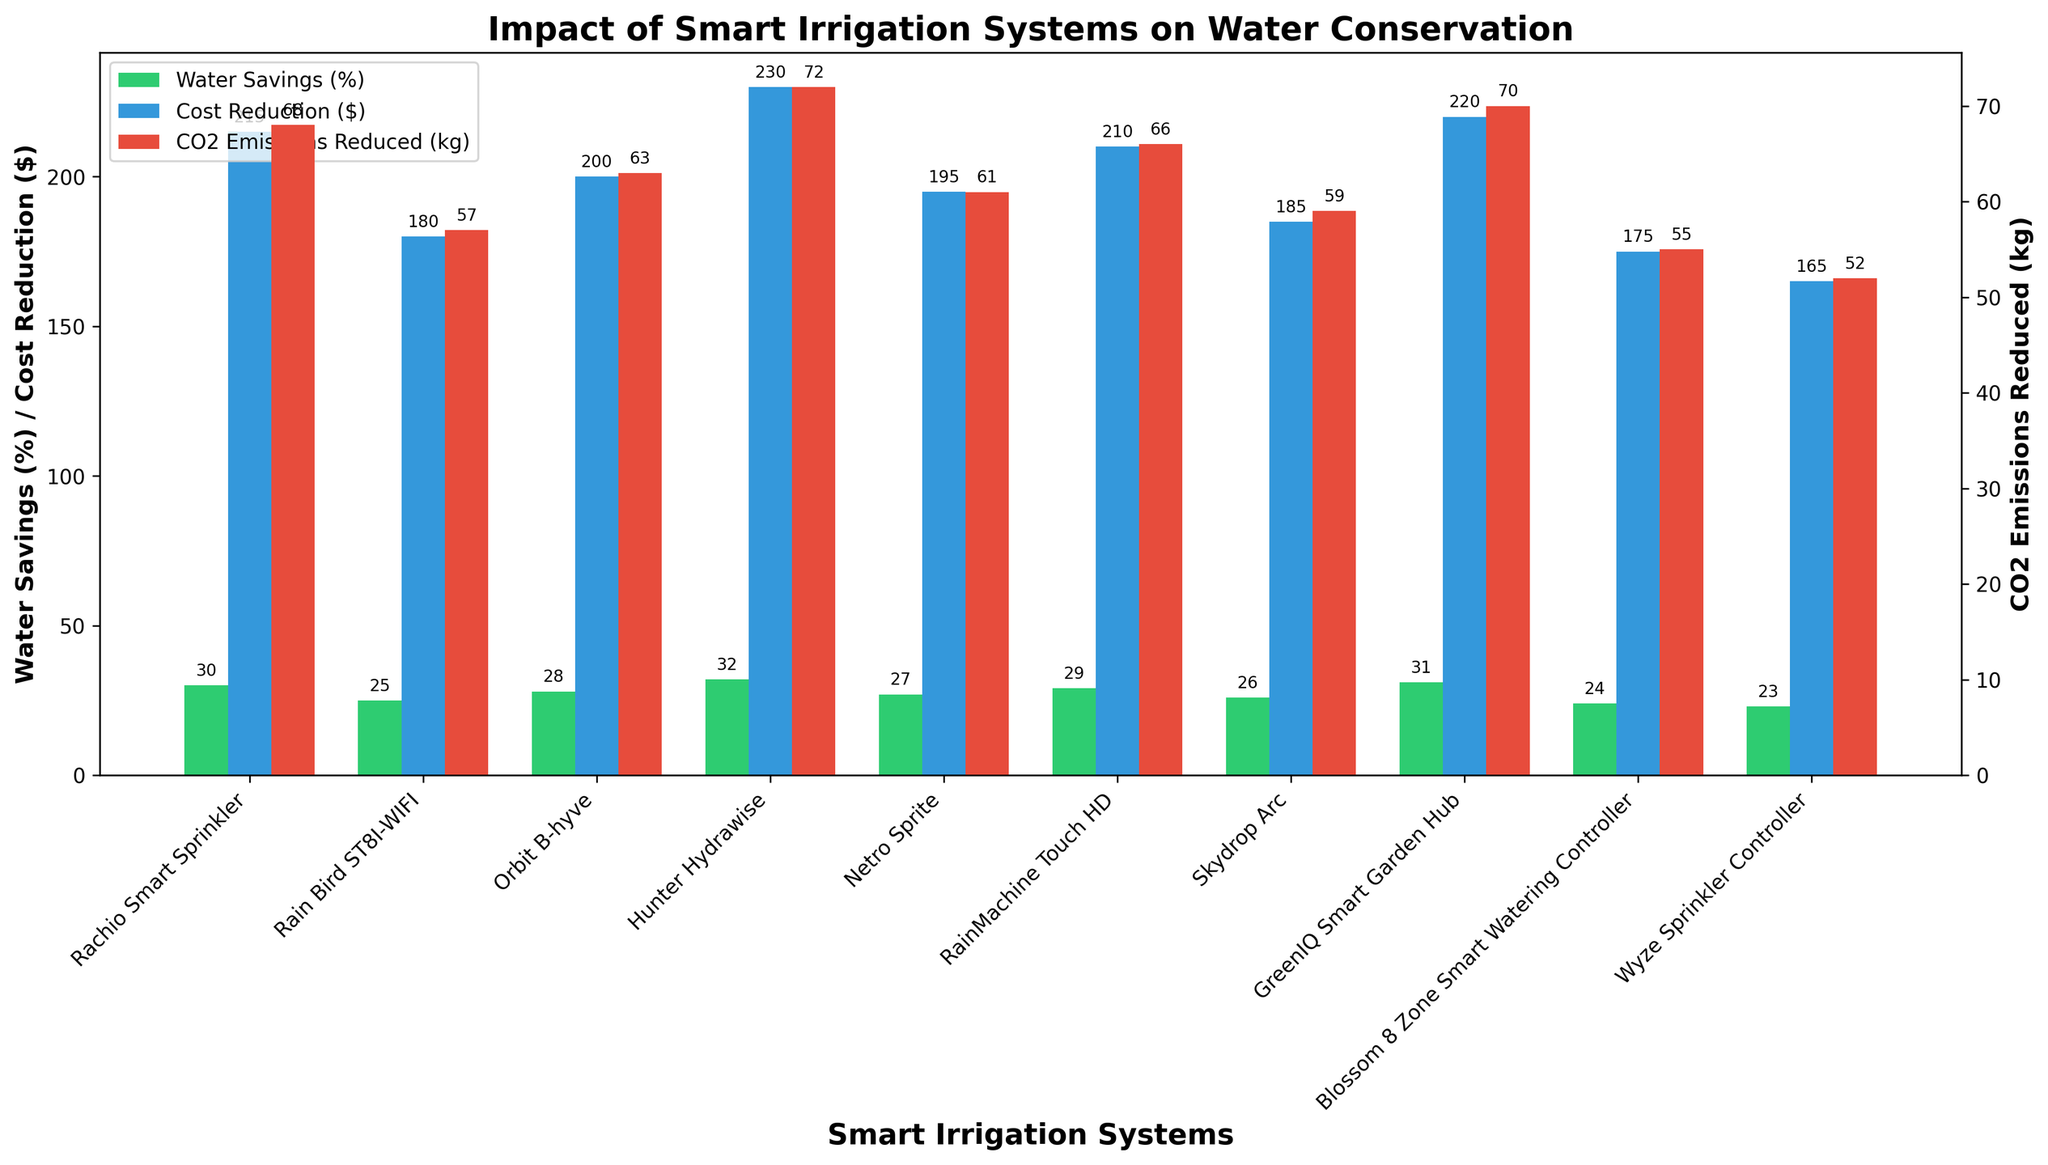Which smart irrigation system has the highest percentage of water savings? By comparing the heights of the green bars corresponding to "Water Savings (%)", the highest bar represents the system with the maximum water savings percentage.
Answer: Hunter Hydrawise Which smart irrigation system has the lowest cost reduction? By inspecting the blue bars for "Cost Reduction ($)", the shortest blue bar identifies the system with the least cost reduction.
Answer: Wyze Sprinkler Controller For the Rachio Smart Sprinkler, what are the values of water savings (%), cost reduction ($), and CO2 emissions reduced (kg)? Locate the "Rachio Smart Sprinkler" on the x-axis, then read the values from the green, blue, and red bars above it.
Answer: 30, 215, 68 Which system contributes to more than 60 kg of CO2 emissions reduced and also has more than 25% water savings? Red bars (CO2 Emissions Reduced) and green bars (Water Savings %) both need to be checked for values above 60 kg and 25%, respectively. The system satisfying both conditions is GreenIQ Smart Garden Hub.
Answer: GreenIQ Smart Garden Hub How much higher is the CO2 emissions reduction of the Hunter Hydrawise compared to the Blossom 8 Zone Smart Watering Controller? Find the red bars for both systems and subtract the height value of Blossom 8 Zone from Hunter Hydrawise. The reduction values are 72 kg and 55 kg, respectively. Thus, the difference is 72 - 55.
Answer: 17 Calculate the average cost reduction of all smart irrigation systems. Sum the values of the blue bars (Cost Reduction $), then divide by the number of systems (10). The sum is 1975, so the average is 1975 / 10.
Answer: 197.5 Which systems have equal water savings percentages? Check the green bars' height values to see if any two or more systems have matching values. Both Orbit B-hyve and RainMachine Touch HD have 28%.
Answer: Orbit B-hyve and RainMachine Touch HD Compare the water savings between the top two performing systems. Hunter Hydrawise (32%) has the highest, followed by GreenIQ Smart Garden Hub (31%). Subtract the second-highest from the highest (32 - 31).
Answer: 1 What is the total CO2 emissions reduced by all systems combined? Add the values of the red bars for all systems. The individual values are 68, 57, 63, 72, 61, 66, 59, 70, 55, 52. Their sum is 623.
Answer: 623 Which system shows the least water savings percentage and how much is it? Checking the green bars, the shortest one for water savings percentage is for Wyze Sprinkler Controller at 23%.
Answer: Wyze Sprinkler Controller, 23 